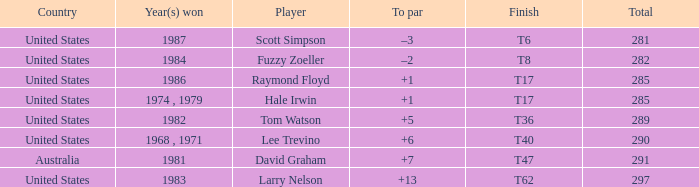What is the year that Hale Irwin won with 285 points? 1974 , 1979. 